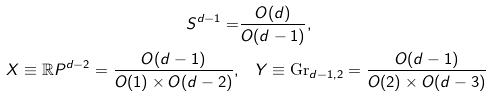<formula> <loc_0><loc_0><loc_500><loc_500>S ^ { d - 1 } = & \frac { O ( d ) } { O ( d - 1 ) } , \\ X \equiv \mathbb { R } P ^ { d - 2 } = \frac { O ( d - 1 ) } { O ( 1 ) \times O ( d - 2 ) } , & \quad Y \equiv \text {Gr} _ { d - 1 , 2 } = \frac { O ( d - 1 ) } { O ( 2 ) \times O ( d - 3 ) }</formula> 